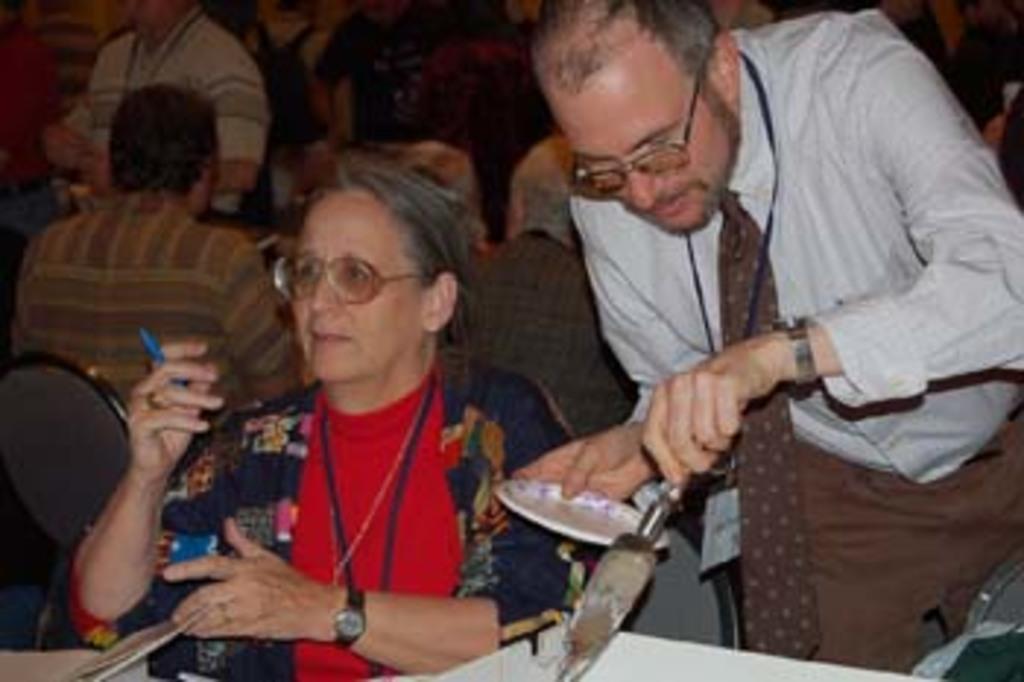How would you summarize this image in a sentence or two? The picture is taken in a restaurant. In the foreground of the picture there is a woman sitting. On the right there is a man standing, holding a plate and a spoon. In the background there are many people sitting in chairs. The background is blurred. 